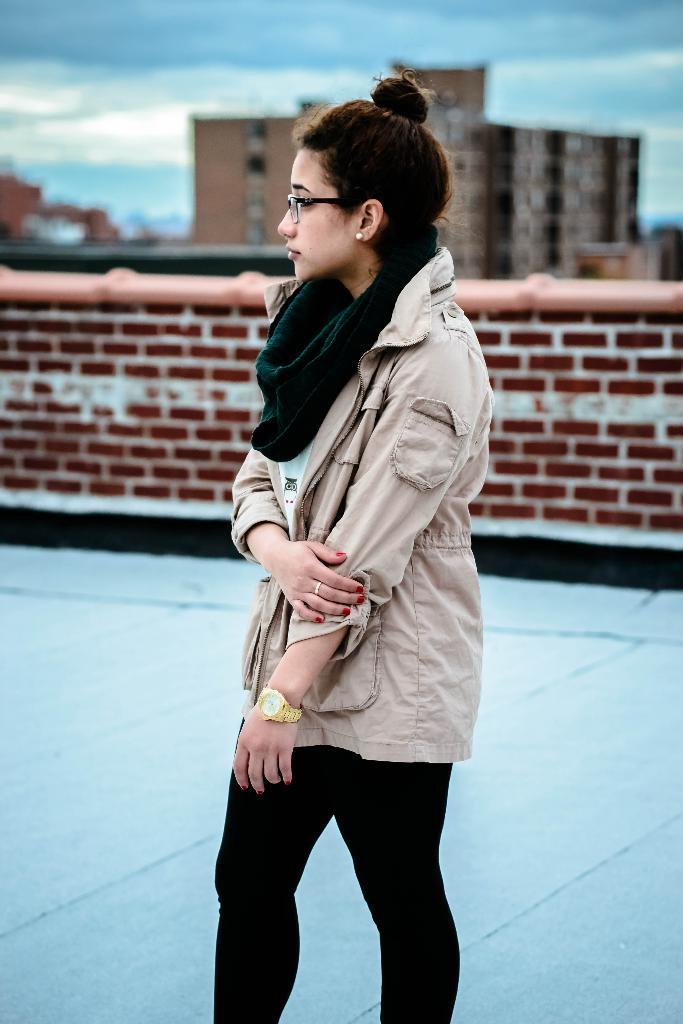Who is present in the image? There is a woman in the image. What is the woman wearing on her lower body? The woman is wearing black pants. What surface is the woman standing on? The woman is standing on the floor. What can be seen in the background of the image? There is a brick wall, a building, and clouds in the sky in the background of the image. What type of swing is the woman using in the image? There is no swing present in the image; the woman is standing on the floor. 